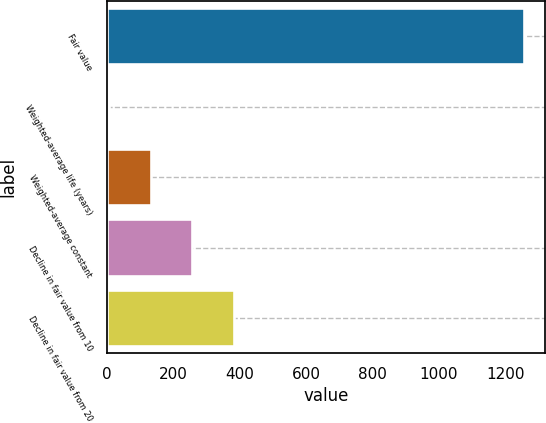Convert chart. <chart><loc_0><loc_0><loc_500><loc_500><bar_chart><fcel>Fair value<fcel>Weighted-average life (years)<fcel>Weighted-average constant<fcel>Decline in fair value from 10<fcel>Decline in fair value from 20<nl><fcel>1257<fcel>6.9<fcel>131.91<fcel>256.92<fcel>381.93<nl></chart> 